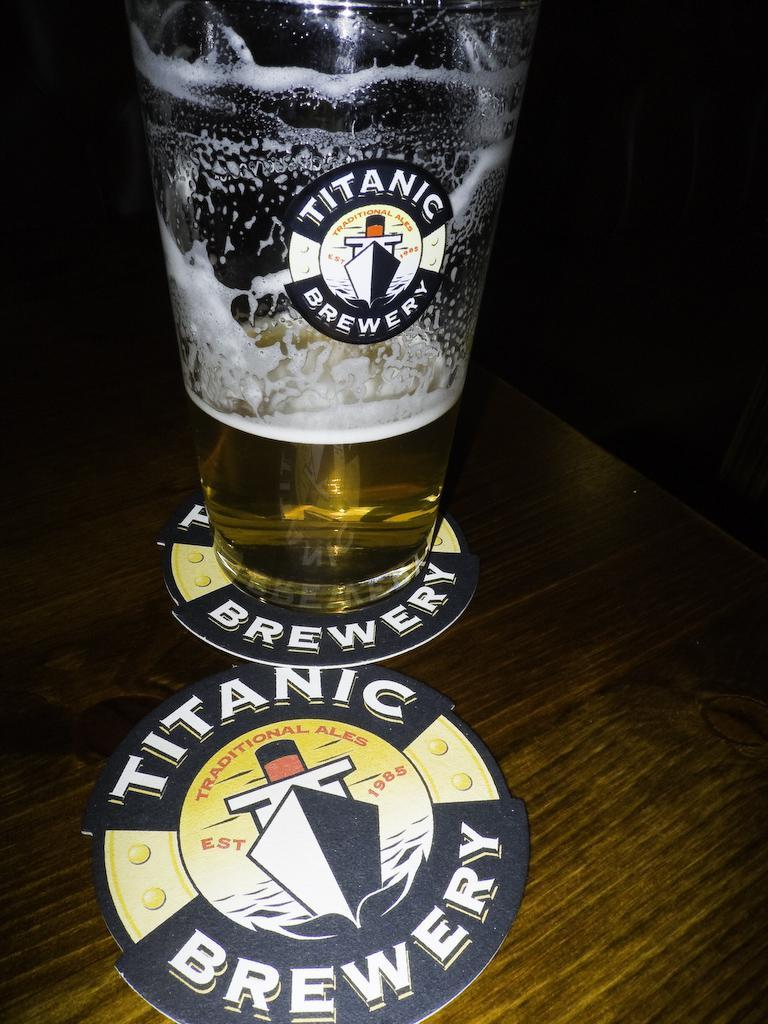<image>
Write a terse but informative summary of the picture. A beer placed on a coaster that says Titanic Brewery. 